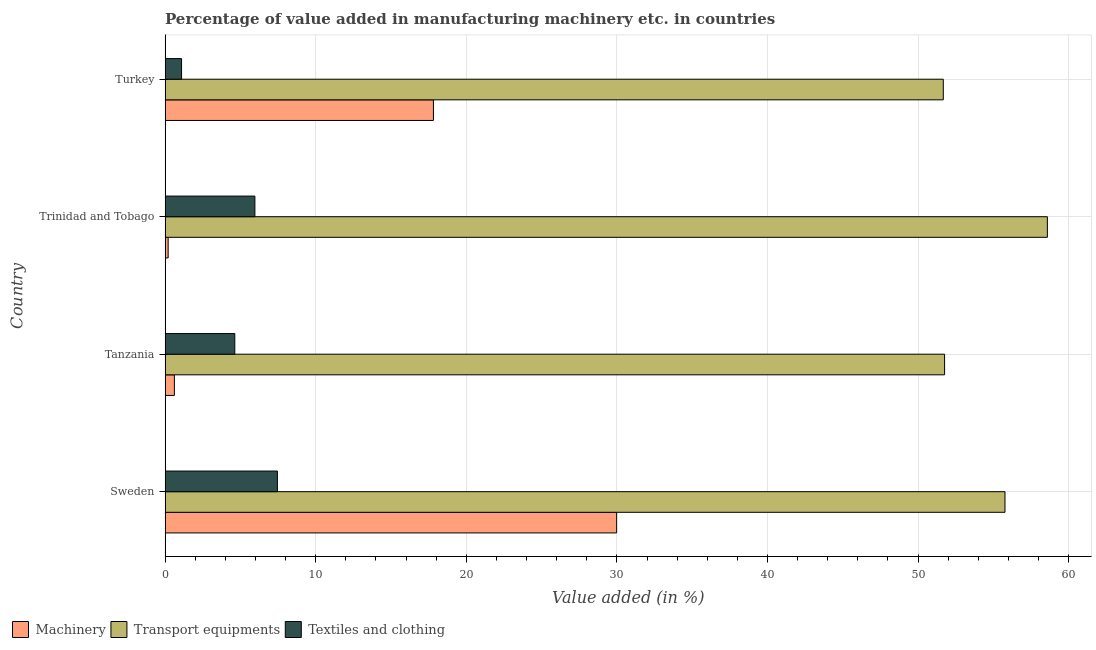How many different coloured bars are there?
Make the answer very short. 3. How many groups of bars are there?
Provide a short and direct response. 4. Are the number of bars on each tick of the Y-axis equal?
Make the answer very short. Yes. How many bars are there on the 3rd tick from the top?
Give a very brief answer. 3. What is the label of the 3rd group of bars from the top?
Your response must be concise. Tanzania. What is the value added in manufacturing textile and clothing in Sweden?
Give a very brief answer. 7.46. Across all countries, what is the maximum value added in manufacturing machinery?
Provide a short and direct response. 29.98. Across all countries, what is the minimum value added in manufacturing textile and clothing?
Your answer should be compact. 1.09. In which country was the value added in manufacturing machinery maximum?
Offer a very short reply. Sweden. In which country was the value added in manufacturing transport equipments minimum?
Your answer should be very brief. Turkey. What is the total value added in manufacturing machinery in the graph?
Ensure brevity in your answer.  48.62. What is the difference between the value added in manufacturing machinery in Tanzania and that in Turkey?
Your answer should be very brief. -17.2. What is the difference between the value added in manufacturing transport equipments in Tanzania and the value added in manufacturing machinery in Trinidad and Tobago?
Ensure brevity in your answer.  51.56. What is the average value added in manufacturing machinery per country?
Offer a very short reply. 12.15. What is the difference between the value added in manufacturing textile and clothing and value added in manufacturing machinery in Sweden?
Your answer should be compact. -22.53. In how many countries, is the value added in manufacturing textile and clothing greater than 8 %?
Keep it short and to the point. 0. What is the ratio of the value added in manufacturing transport equipments in Sweden to that in Turkey?
Provide a succinct answer. 1.08. Is the value added in manufacturing machinery in Sweden less than that in Tanzania?
Give a very brief answer. No. Is the difference between the value added in manufacturing textile and clothing in Trinidad and Tobago and Turkey greater than the difference between the value added in manufacturing machinery in Trinidad and Tobago and Turkey?
Your answer should be compact. Yes. What is the difference between the highest and the second highest value added in manufacturing textile and clothing?
Keep it short and to the point. 1.49. What is the difference between the highest and the lowest value added in manufacturing transport equipments?
Provide a succinct answer. 6.91. In how many countries, is the value added in manufacturing machinery greater than the average value added in manufacturing machinery taken over all countries?
Your response must be concise. 2. Is the sum of the value added in manufacturing transport equipments in Sweden and Tanzania greater than the maximum value added in manufacturing textile and clothing across all countries?
Give a very brief answer. Yes. What does the 2nd bar from the top in Turkey represents?
Your answer should be very brief. Transport equipments. What does the 3rd bar from the bottom in Tanzania represents?
Give a very brief answer. Textiles and clothing. Are all the bars in the graph horizontal?
Your response must be concise. Yes. Where does the legend appear in the graph?
Make the answer very short. Bottom left. How many legend labels are there?
Make the answer very short. 3. What is the title of the graph?
Provide a succinct answer. Percentage of value added in manufacturing machinery etc. in countries. What is the label or title of the X-axis?
Ensure brevity in your answer.  Value added (in %). What is the label or title of the Y-axis?
Keep it short and to the point. Country. What is the Value added (in %) in Machinery in Sweden?
Make the answer very short. 29.98. What is the Value added (in %) in Transport equipments in Sweden?
Offer a terse response. 55.77. What is the Value added (in %) of Textiles and clothing in Sweden?
Provide a short and direct response. 7.46. What is the Value added (in %) in Machinery in Tanzania?
Your answer should be very brief. 0.62. What is the Value added (in %) of Transport equipments in Tanzania?
Your response must be concise. 51.76. What is the Value added (in %) of Textiles and clothing in Tanzania?
Your answer should be compact. 4.63. What is the Value added (in %) in Machinery in Trinidad and Tobago?
Ensure brevity in your answer.  0.2. What is the Value added (in %) of Transport equipments in Trinidad and Tobago?
Provide a succinct answer. 58.59. What is the Value added (in %) of Textiles and clothing in Trinidad and Tobago?
Provide a succinct answer. 5.96. What is the Value added (in %) in Machinery in Turkey?
Provide a short and direct response. 17.82. What is the Value added (in %) of Transport equipments in Turkey?
Your answer should be compact. 51.67. What is the Value added (in %) of Textiles and clothing in Turkey?
Keep it short and to the point. 1.09. Across all countries, what is the maximum Value added (in %) in Machinery?
Provide a short and direct response. 29.98. Across all countries, what is the maximum Value added (in %) in Transport equipments?
Provide a short and direct response. 58.59. Across all countries, what is the maximum Value added (in %) in Textiles and clothing?
Provide a short and direct response. 7.46. Across all countries, what is the minimum Value added (in %) of Machinery?
Your response must be concise. 0.2. Across all countries, what is the minimum Value added (in %) in Transport equipments?
Your answer should be compact. 51.67. Across all countries, what is the minimum Value added (in %) of Textiles and clothing?
Offer a terse response. 1.09. What is the total Value added (in %) in Machinery in the graph?
Give a very brief answer. 48.62. What is the total Value added (in %) in Transport equipments in the graph?
Provide a short and direct response. 217.79. What is the total Value added (in %) in Textiles and clothing in the graph?
Your answer should be very brief. 19.14. What is the difference between the Value added (in %) in Machinery in Sweden and that in Tanzania?
Your answer should be very brief. 29.37. What is the difference between the Value added (in %) of Transport equipments in Sweden and that in Tanzania?
Give a very brief answer. 4.01. What is the difference between the Value added (in %) in Textiles and clothing in Sweden and that in Tanzania?
Keep it short and to the point. 2.83. What is the difference between the Value added (in %) of Machinery in Sweden and that in Trinidad and Tobago?
Your answer should be very brief. 29.78. What is the difference between the Value added (in %) of Transport equipments in Sweden and that in Trinidad and Tobago?
Your answer should be compact. -2.82. What is the difference between the Value added (in %) of Textiles and clothing in Sweden and that in Trinidad and Tobago?
Your response must be concise. 1.49. What is the difference between the Value added (in %) in Machinery in Sweden and that in Turkey?
Keep it short and to the point. 12.17. What is the difference between the Value added (in %) of Transport equipments in Sweden and that in Turkey?
Ensure brevity in your answer.  4.1. What is the difference between the Value added (in %) of Textiles and clothing in Sweden and that in Turkey?
Your answer should be very brief. 6.36. What is the difference between the Value added (in %) in Machinery in Tanzania and that in Trinidad and Tobago?
Make the answer very short. 0.41. What is the difference between the Value added (in %) of Transport equipments in Tanzania and that in Trinidad and Tobago?
Provide a short and direct response. -6.83. What is the difference between the Value added (in %) of Textiles and clothing in Tanzania and that in Trinidad and Tobago?
Make the answer very short. -1.33. What is the difference between the Value added (in %) in Machinery in Tanzania and that in Turkey?
Provide a succinct answer. -17.2. What is the difference between the Value added (in %) in Transport equipments in Tanzania and that in Turkey?
Your answer should be compact. 0.09. What is the difference between the Value added (in %) of Textiles and clothing in Tanzania and that in Turkey?
Make the answer very short. 3.54. What is the difference between the Value added (in %) in Machinery in Trinidad and Tobago and that in Turkey?
Your answer should be compact. -17.61. What is the difference between the Value added (in %) of Transport equipments in Trinidad and Tobago and that in Turkey?
Ensure brevity in your answer.  6.91. What is the difference between the Value added (in %) in Textiles and clothing in Trinidad and Tobago and that in Turkey?
Provide a short and direct response. 4.87. What is the difference between the Value added (in %) in Machinery in Sweden and the Value added (in %) in Transport equipments in Tanzania?
Offer a very short reply. -21.78. What is the difference between the Value added (in %) in Machinery in Sweden and the Value added (in %) in Textiles and clothing in Tanzania?
Offer a very short reply. 25.36. What is the difference between the Value added (in %) of Transport equipments in Sweden and the Value added (in %) of Textiles and clothing in Tanzania?
Your response must be concise. 51.14. What is the difference between the Value added (in %) in Machinery in Sweden and the Value added (in %) in Transport equipments in Trinidad and Tobago?
Provide a short and direct response. -28.6. What is the difference between the Value added (in %) of Machinery in Sweden and the Value added (in %) of Textiles and clothing in Trinidad and Tobago?
Your answer should be compact. 24.02. What is the difference between the Value added (in %) in Transport equipments in Sweden and the Value added (in %) in Textiles and clothing in Trinidad and Tobago?
Keep it short and to the point. 49.81. What is the difference between the Value added (in %) in Machinery in Sweden and the Value added (in %) in Transport equipments in Turkey?
Give a very brief answer. -21.69. What is the difference between the Value added (in %) in Machinery in Sweden and the Value added (in %) in Textiles and clothing in Turkey?
Offer a very short reply. 28.89. What is the difference between the Value added (in %) of Transport equipments in Sweden and the Value added (in %) of Textiles and clothing in Turkey?
Keep it short and to the point. 54.68. What is the difference between the Value added (in %) of Machinery in Tanzania and the Value added (in %) of Transport equipments in Trinidad and Tobago?
Your answer should be very brief. -57.97. What is the difference between the Value added (in %) in Machinery in Tanzania and the Value added (in %) in Textiles and clothing in Trinidad and Tobago?
Provide a short and direct response. -5.35. What is the difference between the Value added (in %) in Transport equipments in Tanzania and the Value added (in %) in Textiles and clothing in Trinidad and Tobago?
Provide a succinct answer. 45.8. What is the difference between the Value added (in %) of Machinery in Tanzania and the Value added (in %) of Transport equipments in Turkey?
Make the answer very short. -51.06. What is the difference between the Value added (in %) in Machinery in Tanzania and the Value added (in %) in Textiles and clothing in Turkey?
Make the answer very short. -0.48. What is the difference between the Value added (in %) in Transport equipments in Tanzania and the Value added (in %) in Textiles and clothing in Turkey?
Ensure brevity in your answer.  50.67. What is the difference between the Value added (in %) of Machinery in Trinidad and Tobago and the Value added (in %) of Transport equipments in Turkey?
Ensure brevity in your answer.  -51.47. What is the difference between the Value added (in %) of Machinery in Trinidad and Tobago and the Value added (in %) of Textiles and clothing in Turkey?
Provide a short and direct response. -0.89. What is the difference between the Value added (in %) of Transport equipments in Trinidad and Tobago and the Value added (in %) of Textiles and clothing in Turkey?
Your answer should be compact. 57.49. What is the average Value added (in %) in Machinery per country?
Your answer should be very brief. 12.16. What is the average Value added (in %) in Transport equipments per country?
Keep it short and to the point. 54.45. What is the average Value added (in %) of Textiles and clothing per country?
Your response must be concise. 4.79. What is the difference between the Value added (in %) of Machinery and Value added (in %) of Transport equipments in Sweden?
Make the answer very short. -25.79. What is the difference between the Value added (in %) in Machinery and Value added (in %) in Textiles and clothing in Sweden?
Keep it short and to the point. 22.53. What is the difference between the Value added (in %) in Transport equipments and Value added (in %) in Textiles and clothing in Sweden?
Your answer should be compact. 48.31. What is the difference between the Value added (in %) of Machinery and Value added (in %) of Transport equipments in Tanzania?
Your answer should be very brief. -51.14. What is the difference between the Value added (in %) of Machinery and Value added (in %) of Textiles and clothing in Tanzania?
Offer a terse response. -4.01. What is the difference between the Value added (in %) in Transport equipments and Value added (in %) in Textiles and clothing in Tanzania?
Offer a very short reply. 47.13. What is the difference between the Value added (in %) in Machinery and Value added (in %) in Transport equipments in Trinidad and Tobago?
Offer a terse response. -58.38. What is the difference between the Value added (in %) of Machinery and Value added (in %) of Textiles and clothing in Trinidad and Tobago?
Provide a succinct answer. -5.76. What is the difference between the Value added (in %) in Transport equipments and Value added (in %) in Textiles and clothing in Trinidad and Tobago?
Provide a succinct answer. 52.62. What is the difference between the Value added (in %) of Machinery and Value added (in %) of Transport equipments in Turkey?
Your answer should be very brief. -33.86. What is the difference between the Value added (in %) in Machinery and Value added (in %) in Textiles and clothing in Turkey?
Your answer should be very brief. 16.72. What is the difference between the Value added (in %) in Transport equipments and Value added (in %) in Textiles and clothing in Turkey?
Offer a terse response. 50.58. What is the ratio of the Value added (in %) of Machinery in Sweden to that in Tanzania?
Provide a succinct answer. 48.64. What is the ratio of the Value added (in %) of Transport equipments in Sweden to that in Tanzania?
Ensure brevity in your answer.  1.08. What is the ratio of the Value added (in %) in Textiles and clothing in Sweden to that in Tanzania?
Your answer should be very brief. 1.61. What is the ratio of the Value added (in %) of Machinery in Sweden to that in Trinidad and Tobago?
Give a very brief answer. 147.43. What is the ratio of the Value added (in %) in Textiles and clothing in Sweden to that in Trinidad and Tobago?
Provide a succinct answer. 1.25. What is the ratio of the Value added (in %) of Machinery in Sweden to that in Turkey?
Give a very brief answer. 1.68. What is the ratio of the Value added (in %) in Transport equipments in Sweden to that in Turkey?
Provide a succinct answer. 1.08. What is the ratio of the Value added (in %) in Textiles and clothing in Sweden to that in Turkey?
Offer a terse response. 6.82. What is the ratio of the Value added (in %) of Machinery in Tanzania to that in Trinidad and Tobago?
Make the answer very short. 3.03. What is the ratio of the Value added (in %) of Transport equipments in Tanzania to that in Trinidad and Tobago?
Offer a very short reply. 0.88. What is the ratio of the Value added (in %) in Textiles and clothing in Tanzania to that in Trinidad and Tobago?
Provide a short and direct response. 0.78. What is the ratio of the Value added (in %) of Machinery in Tanzania to that in Turkey?
Provide a succinct answer. 0.03. What is the ratio of the Value added (in %) in Textiles and clothing in Tanzania to that in Turkey?
Your answer should be very brief. 4.23. What is the ratio of the Value added (in %) of Machinery in Trinidad and Tobago to that in Turkey?
Offer a terse response. 0.01. What is the ratio of the Value added (in %) in Transport equipments in Trinidad and Tobago to that in Turkey?
Offer a very short reply. 1.13. What is the ratio of the Value added (in %) in Textiles and clothing in Trinidad and Tobago to that in Turkey?
Your response must be concise. 5.45. What is the difference between the highest and the second highest Value added (in %) of Machinery?
Your response must be concise. 12.17. What is the difference between the highest and the second highest Value added (in %) of Transport equipments?
Offer a very short reply. 2.82. What is the difference between the highest and the second highest Value added (in %) in Textiles and clothing?
Your answer should be very brief. 1.49. What is the difference between the highest and the lowest Value added (in %) of Machinery?
Give a very brief answer. 29.78. What is the difference between the highest and the lowest Value added (in %) of Transport equipments?
Offer a terse response. 6.91. What is the difference between the highest and the lowest Value added (in %) in Textiles and clothing?
Your response must be concise. 6.36. 